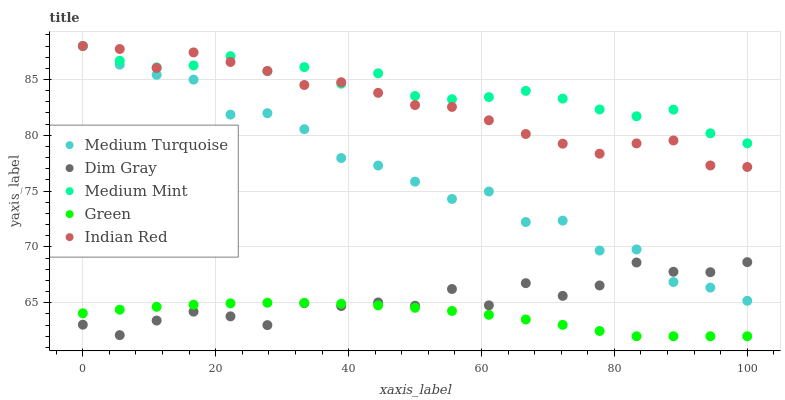Does Green have the minimum area under the curve?
Answer yes or no. Yes. Does Medium Mint have the maximum area under the curve?
Answer yes or no. Yes. Does Dim Gray have the minimum area under the curve?
Answer yes or no. No. Does Dim Gray have the maximum area under the curve?
Answer yes or no. No. Is Green the smoothest?
Answer yes or no. Yes. Is Medium Turquoise the roughest?
Answer yes or no. Yes. Is Dim Gray the smoothest?
Answer yes or no. No. Is Dim Gray the roughest?
Answer yes or no. No. Does Green have the lowest value?
Answer yes or no. Yes. Does Dim Gray have the lowest value?
Answer yes or no. No. Does Medium Turquoise have the highest value?
Answer yes or no. Yes. Does Dim Gray have the highest value?
Answer yes or no. No. Is Green less than Medium Mint?
Answer yes or no. Yes. Is Medium Mint greater than Green?
Answer yes or no. Yes. Does Green intersect Dim Gray?
Answer yes or no. Yes. Is Green less than Dim Gray?
Answer yes or no. No. Is Green greater than Dim Gray?
Answer yes or no. No. Does Green intersect Medium Mint?
Answer yes or no. No. 